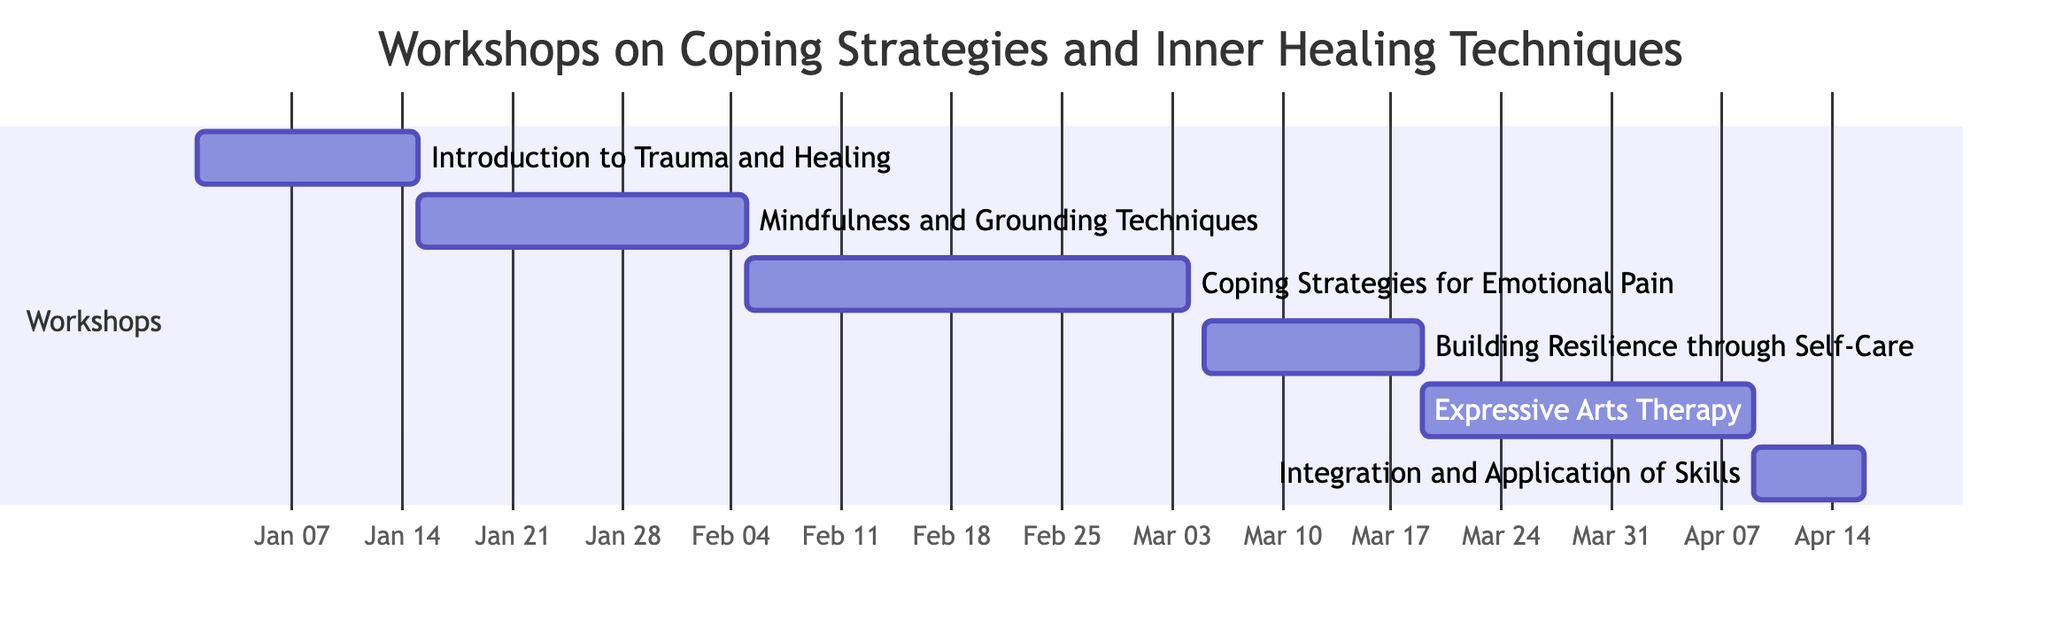What is the duration of the "Mindfulness and Grounding Techniques" workshop? The diagram shows that the "Mindfulness and Grounding Techniques" workshop lasts for 3 weeks. This information can be found directly next to the workshop's title.
Answer: 3 weeks When does the "Coping Strategies for Emotional Pain" workshop end? To find the end date of "Coping Strategies for Emotional Pain", we look at the start date (February 5) and the duration (4 weeks). Adding 4 weeks to the start date gives us an end date of March 4, 2024.
Answer: March 4, 2024 Which workshop overlaps with "Building Resilience through Self-Care"? The "Building Resilience through Self-Care" workshop starts on March 5 and ends on March 18. The subsequent workshop, "Expressive Arts Therapy," starts on March 19. Thus, the only workshop that overlaps is "Coping Strategies for Emotional Pain."
Answer: Coping Strategies for Emotional Pain How many workshops start in January? The diagram indicates that there are two workshops starting in January: "Introduction to Trauma and Healing" (January 1) and "Mindfulness and Grounding Techniques" (January 15). Thus, we count these two workshops.
Answer: 2 What is the start date of the last workshop? The last workshop shown in the diagram is "Integration and Application of Skills," which has a start date of April 9, 2024. This is explicitly mentioned next to the workshop's title.
Answer: April 9, 2024 Which workshop has the longest duration? By examining the durations listed for each workshop, "Coping Strategies for Emotional Pain" has the longest duration of 4 weeks, compared to others which range from 1 to 3 weeks.
Answer: Coping Strategies for Emotional Pain How many workshops are scheduled in total? The diagram lists a total of six workshops under the section 'Workshops'. Each workshop entry is clearly delineated, allowing for a straightforward count.
Answer: 6 When does the "Expressive Arts Therapy" workshop begin? The start date for "Expressive Arts Therapy" is explicitly provided in the diagram as March 19, 2024. Therefore, the answer is directly obtained from the data presented.
Answer: March 19, 2024 